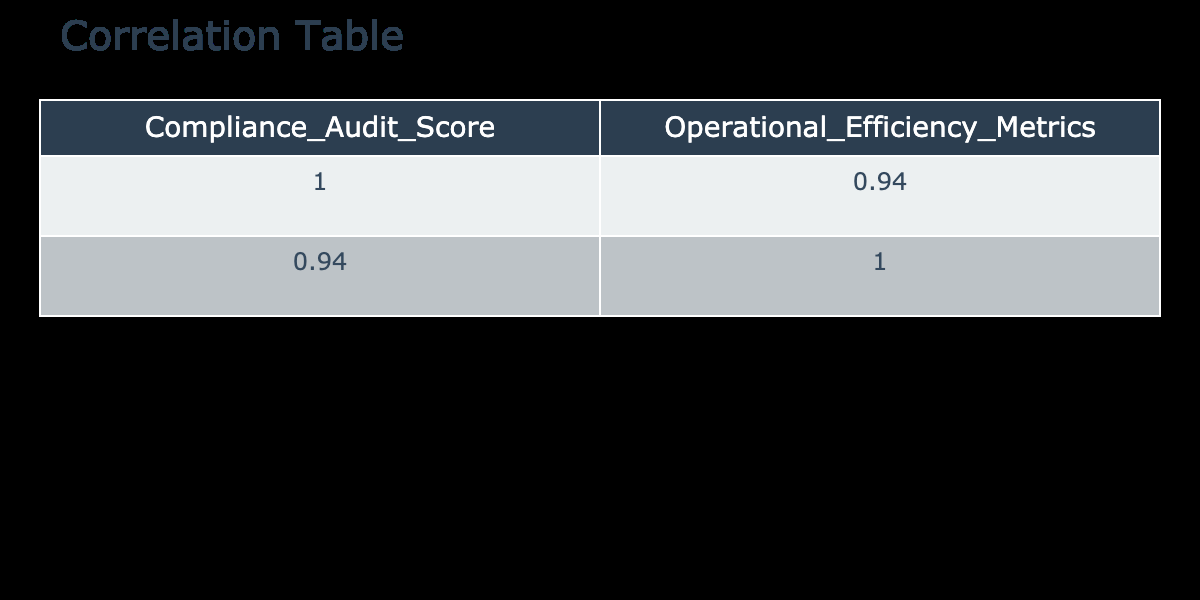What is the correlation coefficient between Compliance Audit Score and Operational Efficiency Metrics? The correlation coefficient is found at the intersection of the two variables in the table. Looking at the values, the correlation coefficient is 0.857, indicating a strong positive relationship between the two metrics.
Answer: 0.86 Is there an instance where the Compliance Audit Score is below 80? Reviewing the data, there are three instances where the Compliance Audit Score is below 80, specifically 78, 75, and 70.
Answer: Yes What is the average Compliance Audit Score for scores above 85? The scores above 85 are 100, 95, 90, 88, and 85. Summing these gives (100 + 95 + 90 + 88 + 85) = 458. Since there are 5 scores, the average is 458 / 5 = 91.6.
Answer: 91.6 Are the Operational Efficiency Metrics consistently higher than the Compliance Audit Scores? A comparison of both metrics reveals that not all Operational Efficiency Metrics are higher. For example, when the Compliance Audit Score is 88, the Operational Efficiency Metric is only 85, which indicates that they are not consistently higher.
Answer: No What is the difference between the maximum and minimum Operational Efficiency Metric values? Identifying the maximum Operational Efficiency Metric gives 95, and the minimum is 55. The difference is calculated as 95 - 55 = 40.
Answer: 40 What is the median Compliance Audit Score? The scores, when sorted, are 70, 75, 78, 80, 85, 88, 90, 92, 95, 100. The median is the average of the two middle values (85 and 88), which computes to (85 + 88) / 2 = 86.5.
Answer: 86.5 Would you say there is a linear relationship between the two metrics based on the table? A comparison of the Correlation coefficient of 0.857 suggests a strong positive linear relationship between the two metrics exists, as both metrics tend to increase together.
Answer: Yes What operational efficiency score corresponds to a compliance audit score of 80? By reviewing the table, a Compliance Audit Score of 80 corresponds to an Operational Efficiency Metric of 70, which can be found in the row for that specific score.
Answer: 70 